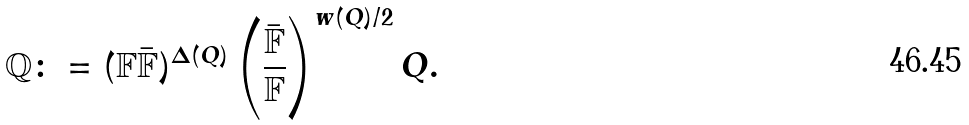<formula> <loc_0><loc_0><loc_500><loc_500>\mathbb { Q } \colon = ( \mathbb { F } \bar { \mathbb { F } } ) ^ { \Delta ( Q ) } \left ( \frac { \bar { \mathbb { F } } } { \mathbb { F } } \right ) ^ { w ( Q ) / 2 } Q .</formula> 